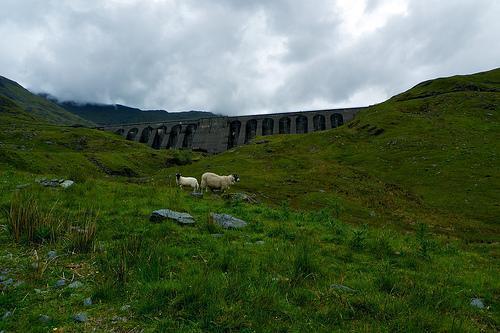How many sheep on the field?
Give a very brief answer. 2. 